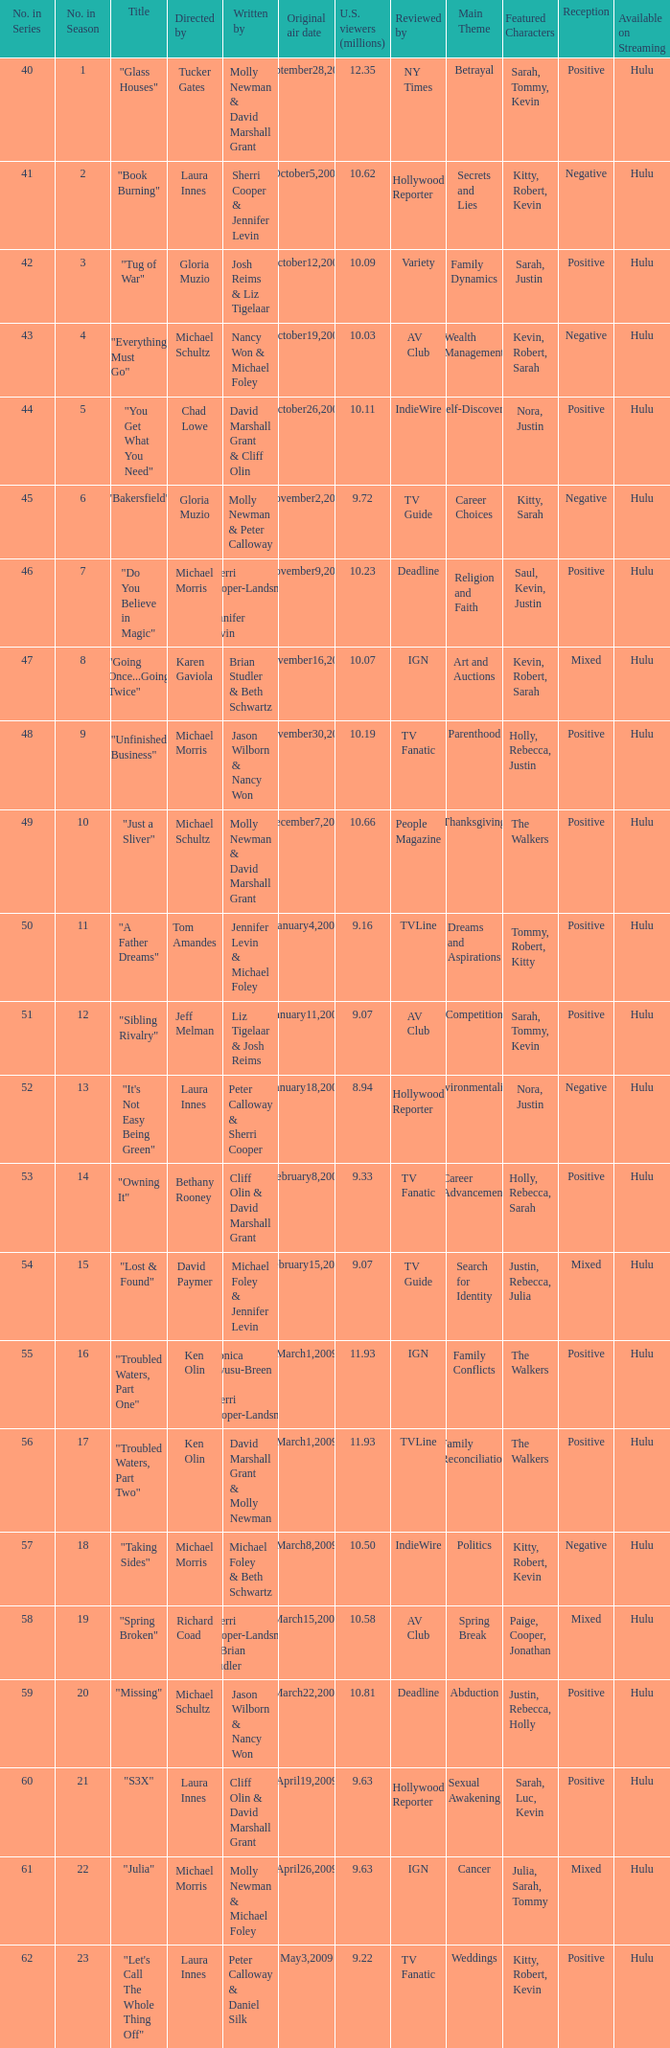What's the name of the episode seen by 9.63 millions of people in the US, whose director is Laura Innes? "S3X". 